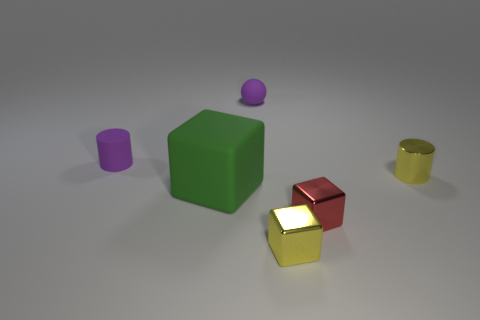Subtract all metallic cubes. How many cubes are left? 1 Add 3 small yellow objects. How many objects exist? 9 Subtract all yellow cubes. How many cubes are left? 2 Subtract all balls. How many objects are left? 5 Subtract 1 cubes. How many cubes are left? 2 Subtract all small yellow metallic cylinders. Subtract all tiny objects. How many objects are left? 0 Add 3 purple things. How many purple things are left? 5 Add 2 metal cylinders. How many metal cylinders exist? 3 Subtract 0 blue blocks. How many objects are left? 6 Subtract all gray blocks. Subtract all gray spheres. How many blocks are left? 3 